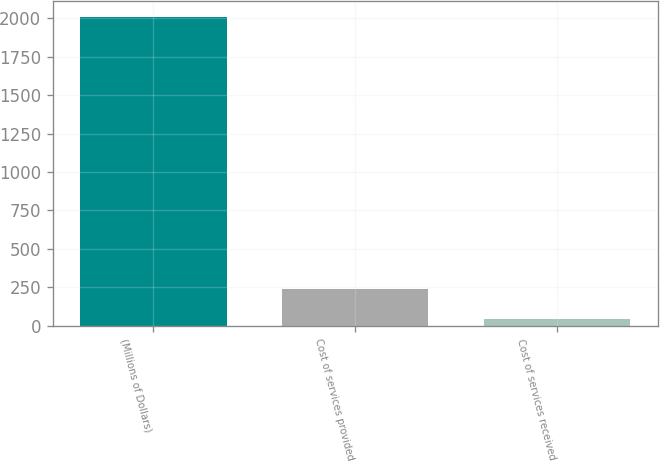<chart> <loc_0><loc_0><loc_500><loc_500><bar_chart><fcel>(Millions of Dollars)<fcel>Cost of services provided<fcel>Cost of services received<nl><fcel>2010<fcel>241.5<fcel>45<nl></chart> 